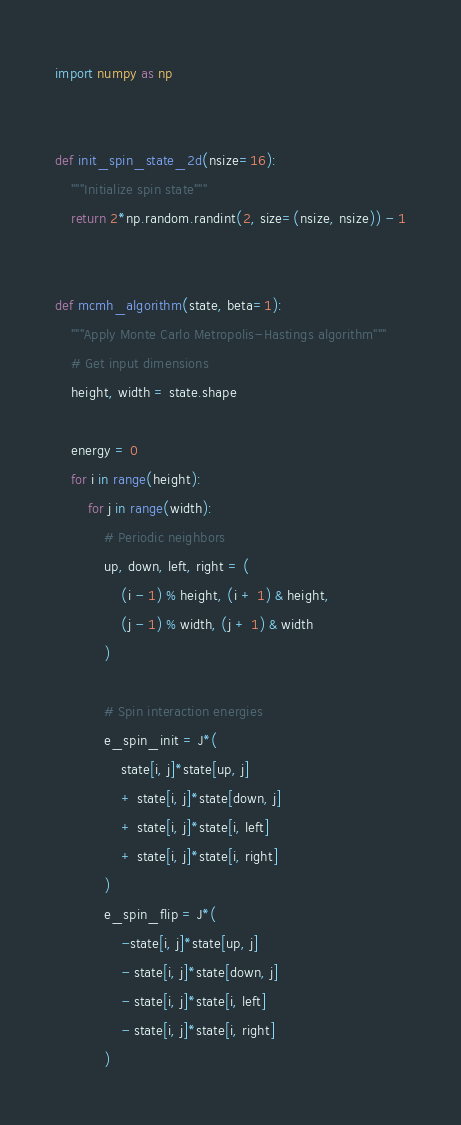Convert code to text. <code><loc_0><loc_0><loc_500><loc_500><_Python_>import numpy as np


def init_spin_state_2d(nsize=16):
    """Initialize spin state"""
    return 2*np.random.randint(2, size=(nsize, nsize)) - 1


def mcmh_algorithm(state, beta=1):
    """Apply Monte Carlo Metropolis-Hastings algorithm"""
    # Get input dimensions
    height, width = state.shape

    energy = 0
    for i in range(height):
        for j in range(width):
            # Periodic neighbors
            up, down, left, right = (
                (i - 1) % height, (i + 1) & height,
                (j - 1) % width, (j + 1) & width
            )

            # Spin interaction energies
            e_spin_init = J*(
                state[i, j]*state[up, j] 
                + state[i, j]*state[down, j]
                + state[i, j]*state[i, left]
                + state[i, j]*state[i, right]
            )
            e_spin_flip = J*(
                -state[i, j]*state[up, j]
                - state[i, j]*state[down, j]
                - state[i, j]*state[i, left]
                - state[i, j]*state[i, right]
            ) </code> 